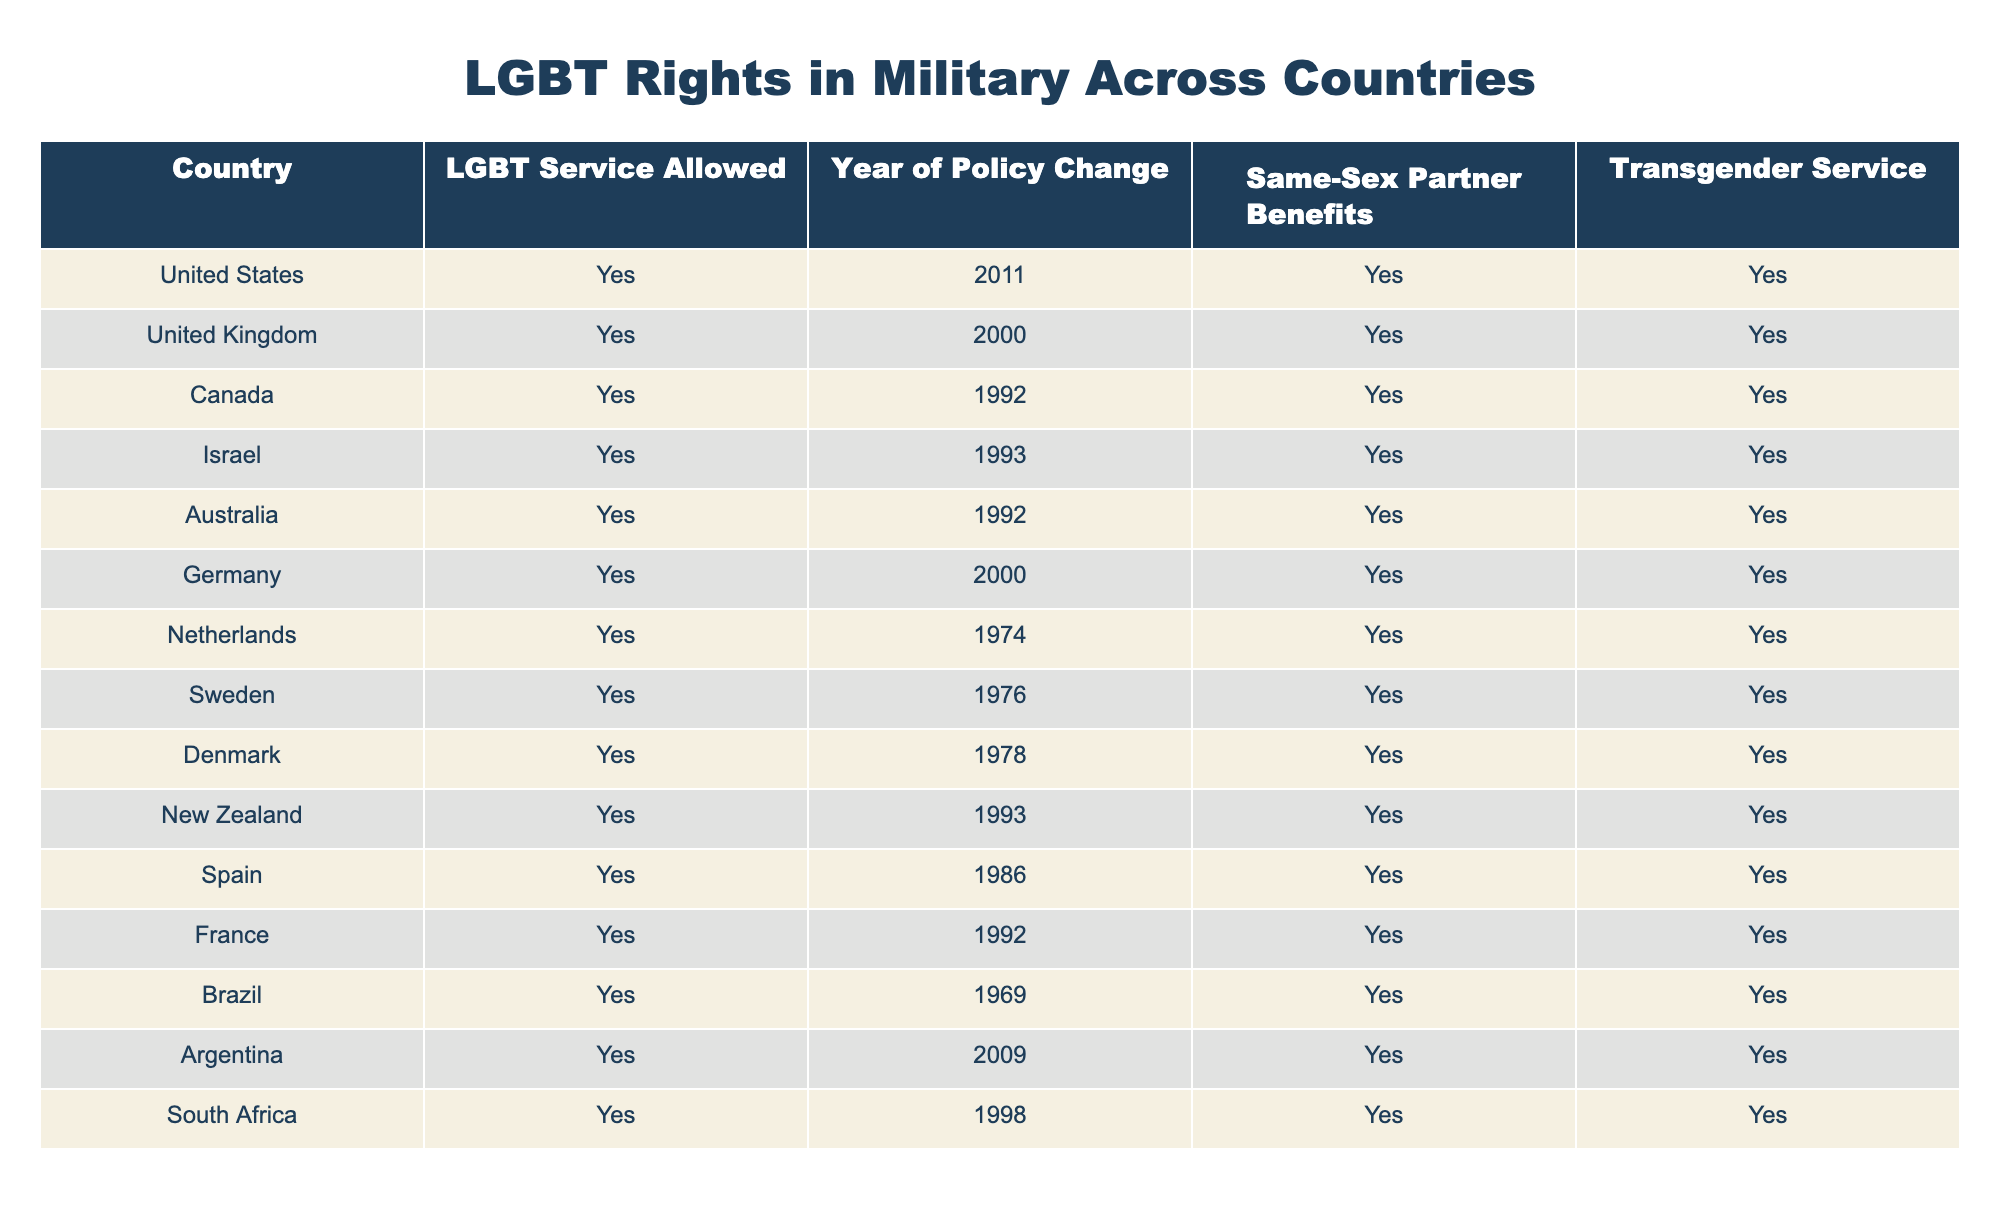What year did Canada allow LGBT service members? Canada allowed LGBT service members in 1992, which can be found in the respective row for Canada under the "Year of Policy Change" column.
Answer: 1992 Are same-sex partner benefits provided in South Africa? South Africa is marked as "Yes" in the "Same-Sex Partner Benefits" column, indicating that same-sex partner benefits are provided to service members.
Answer: Yes Which country was the first to allow LGBT service members? By examining the "Year of Policy Change" column, the earliest year listed is 1974 for the Netherlands. Therefore, the Netherlands was the first country to allow LGBT service members.
Answer: Netherlands How many countries listed allowed LGBT service before the year 2000? Counting the countries in the table that allowed LGBT service before 2000 provides the following years: Netherlands (1974), Sweden (1976), Denmark (1978), and Brazil (1969), giving us a total of 4 countries.
Answer: 4 Is there any country that has both same-sex partner benefits and transgender service? By reviewing the table, all countries listed have "Yes" for both "Same-Sex Partner Benefits" and "Transgender Service," indicating that every country provides these benefits.
Answer: Yes What is the median year of policy change for LGBT service acceptance across these countries? The years of policy change in the table are: 1969, 1974, 1976, 1978, 1992, 1992, 1993, 1993, 1998, 2000, 2000, 2009, and 2011. When sorted, the median (the middle value) is the average of the 6th and 7th entries (1992 and 1993), which is (1992 + 1993) / 2 = 1992.5.
Answer: 1992.5 Which country implemented its policy of LGBT service most recently? The country that enacted its policy last is the United States, which changed its policy in 2011, as evident in the "Year of Policy Change" column.
Answer: United States Do all countries in the list allow transgender service? Yes, each row marked in the "Transgender Service" column is labeled "Yes," showing that all countries allow transgender individuals to serve.
Answer: Yes What percentage of countries provide same-sex partner benefits? There are 14 countries total, and all 14 provide same-sex partner benefits. Therefore, the percentage is (14/14) * 100, which equals 100%.
Answer: 100% 